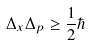Convert formula to latex. <formula><loc_0><loc_0><loc_500><loc_500>\Delta _ { x } \Delta _ { p } \geq { \frac { 1 } { 2 } } \hbar</formula> 